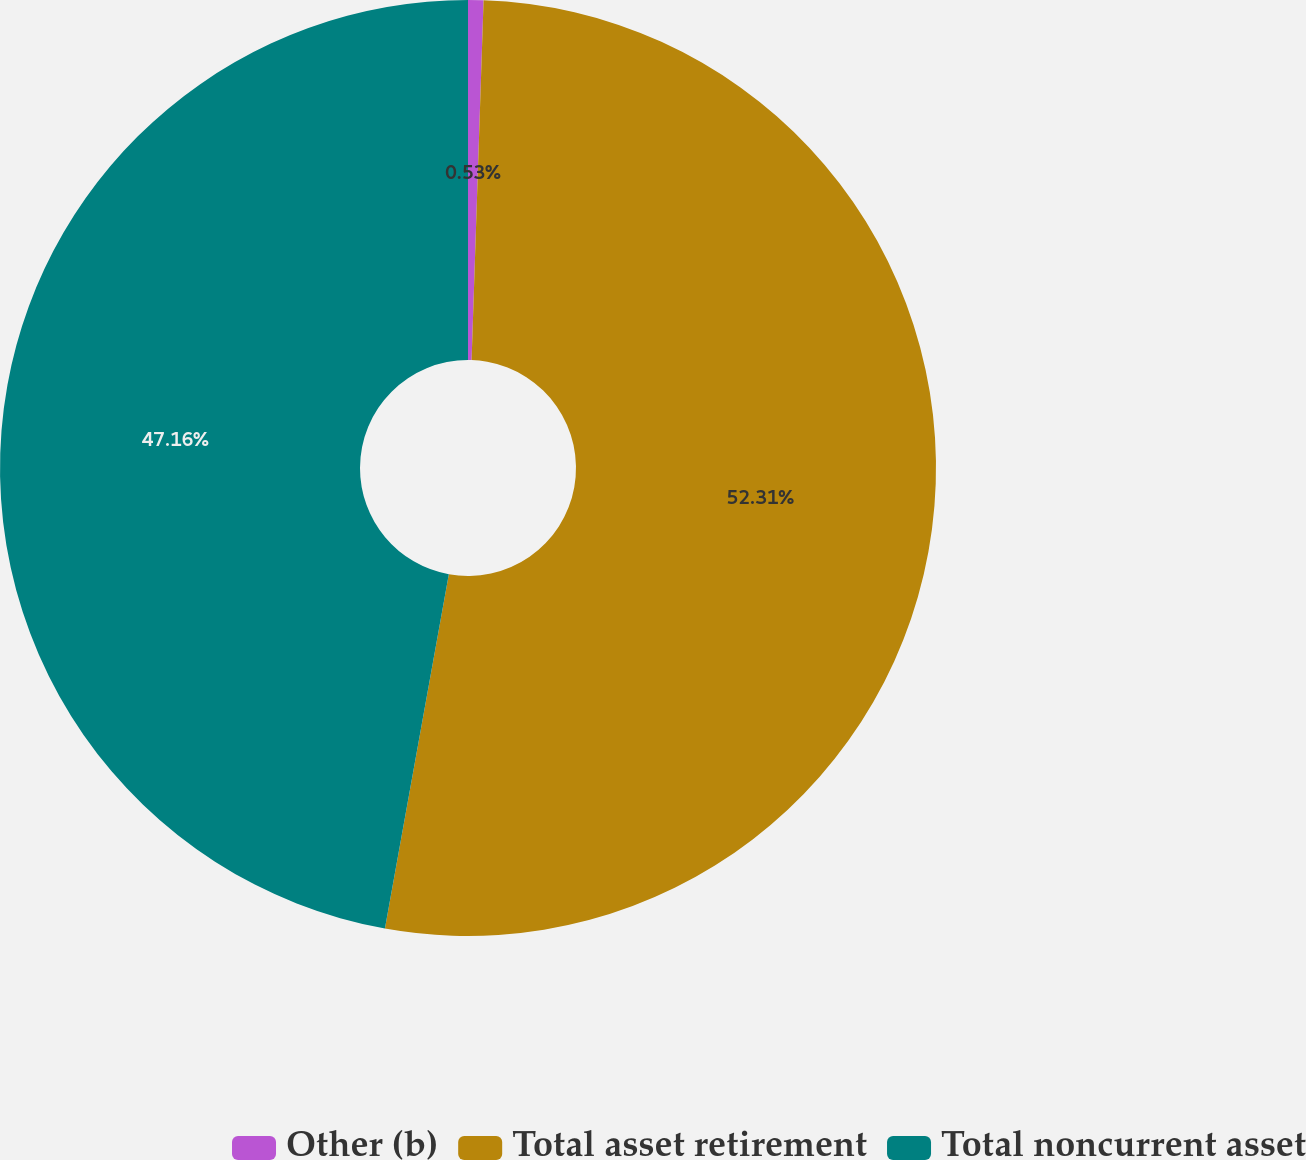<chart> <loc_0><loc_0><loc_500><loc_500><pie_chart><fcel>Other (b)<fcel>Total asset retirement<fcel>Total noncurrent asset<nl><fcel>0.53%<fcel>52.31%<fcel>47.16%<nl></chart> 